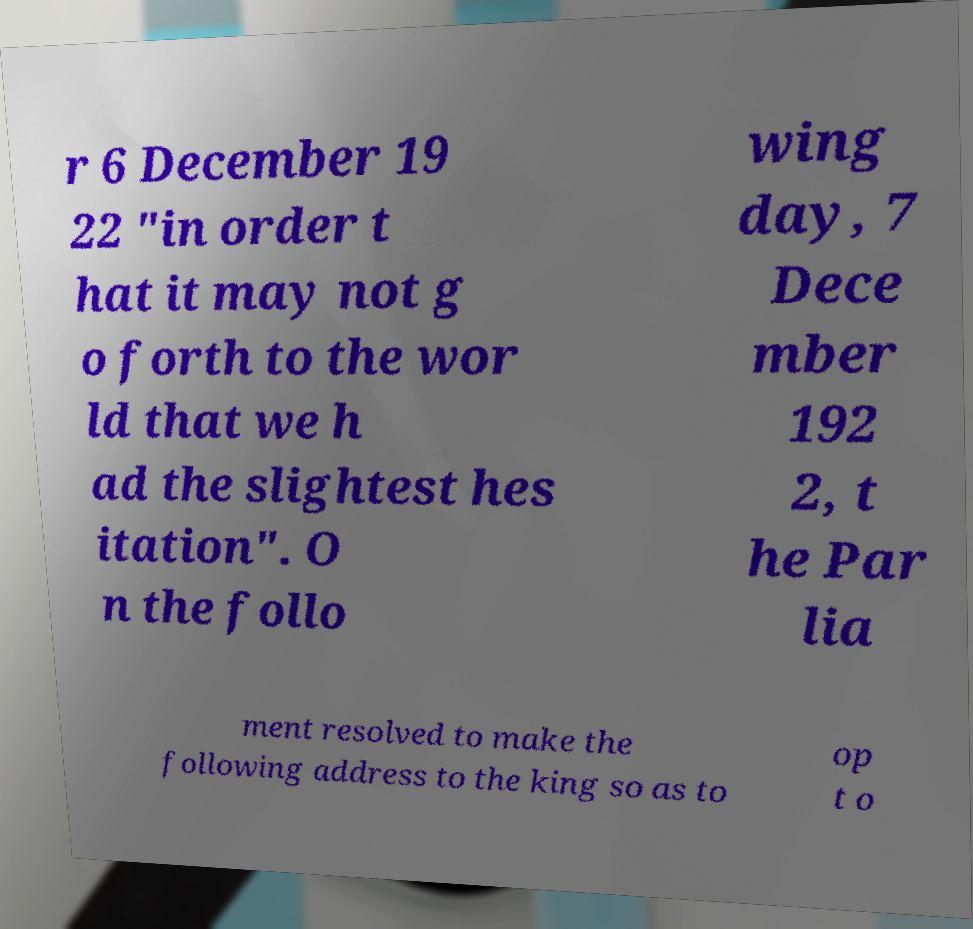Please identify and transcribe the text found in this image. r 6 December 19 22 "in order t hat it may not g o forth to the wor ld that we h ad the slightest hes itation". O n the follo wing day, 7 Dece mber 192 2, t he Par lia ment resolved to make the following address to the king so as to op t o 